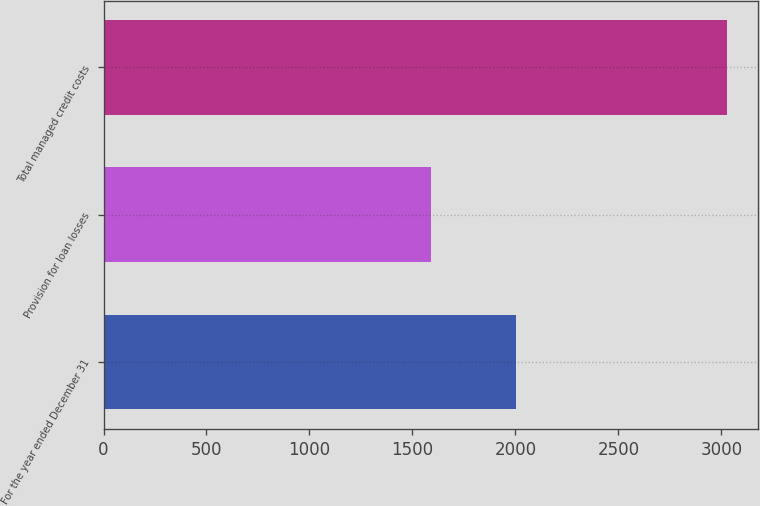<chart> <loc_0><loc_0><loc_500><loc_500><bar_chart><fcel>For the year ended December 31<fcel>Provision for loan losses<fcel>Total managed credit costs<nl><fcel>2002<fcel>1589<fcel>3028<nl></chart> 